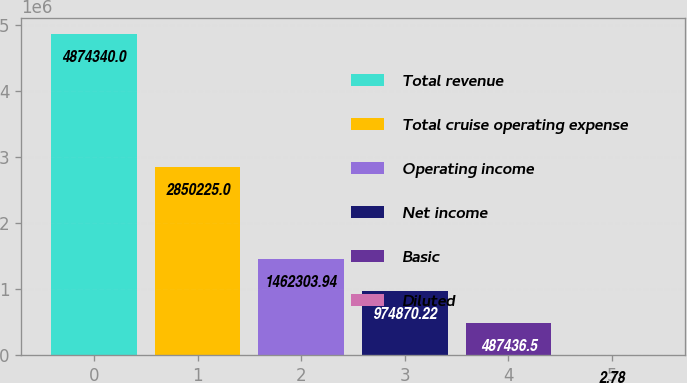<chart> <loc_0><loc_0><loc_500><loc_500><bar_chart><fcel>Total revenue<fcel>Total cruise operating expense<fcel>Operating income<fcel>Net income<fcel>Basic<fcel>Diluted<nl><fcel>4.87434e+06<fcel>2.85022e+06<fcel>1.4623e+06<fcel>974870<fcel>487436<fcel>2.78<nl></chart> 